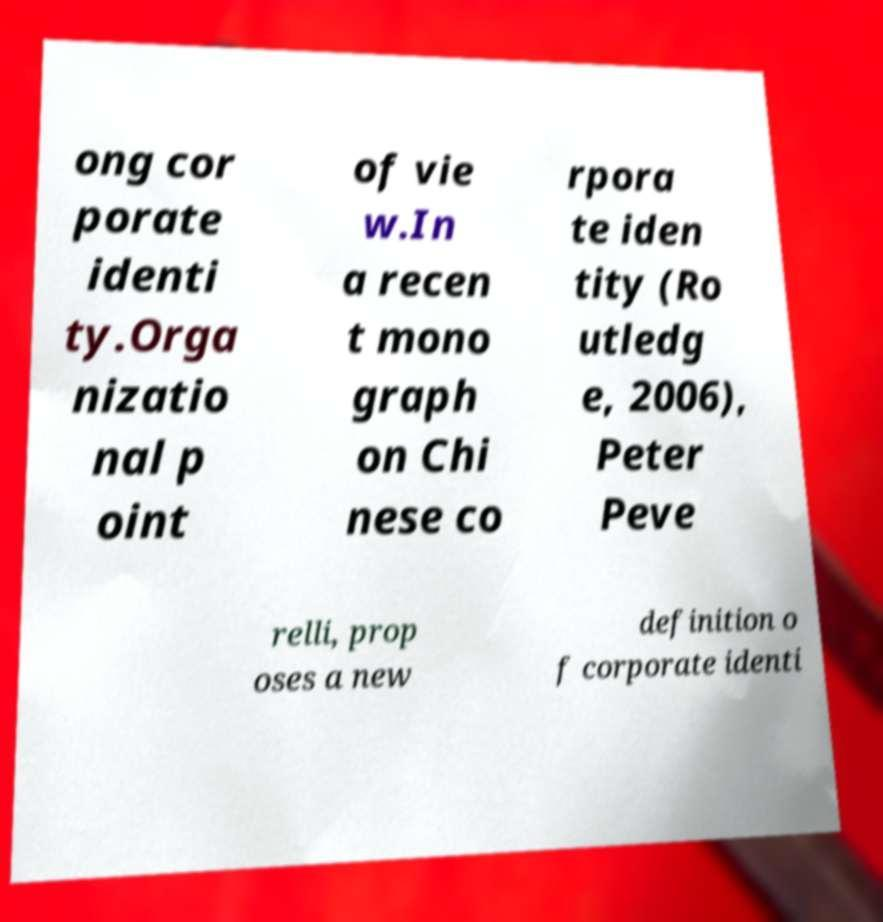What messages or text are displayed in this image? I need them in a readable, typed format. ong cor porate identi ty.Orga nizatio nal p oint of vie w.In a recen t mono graph on Chi nese co rpora te iden tity (Ro utledg e, 2006), Peter Peve relli, prop oses a new definition o f corporate identi 